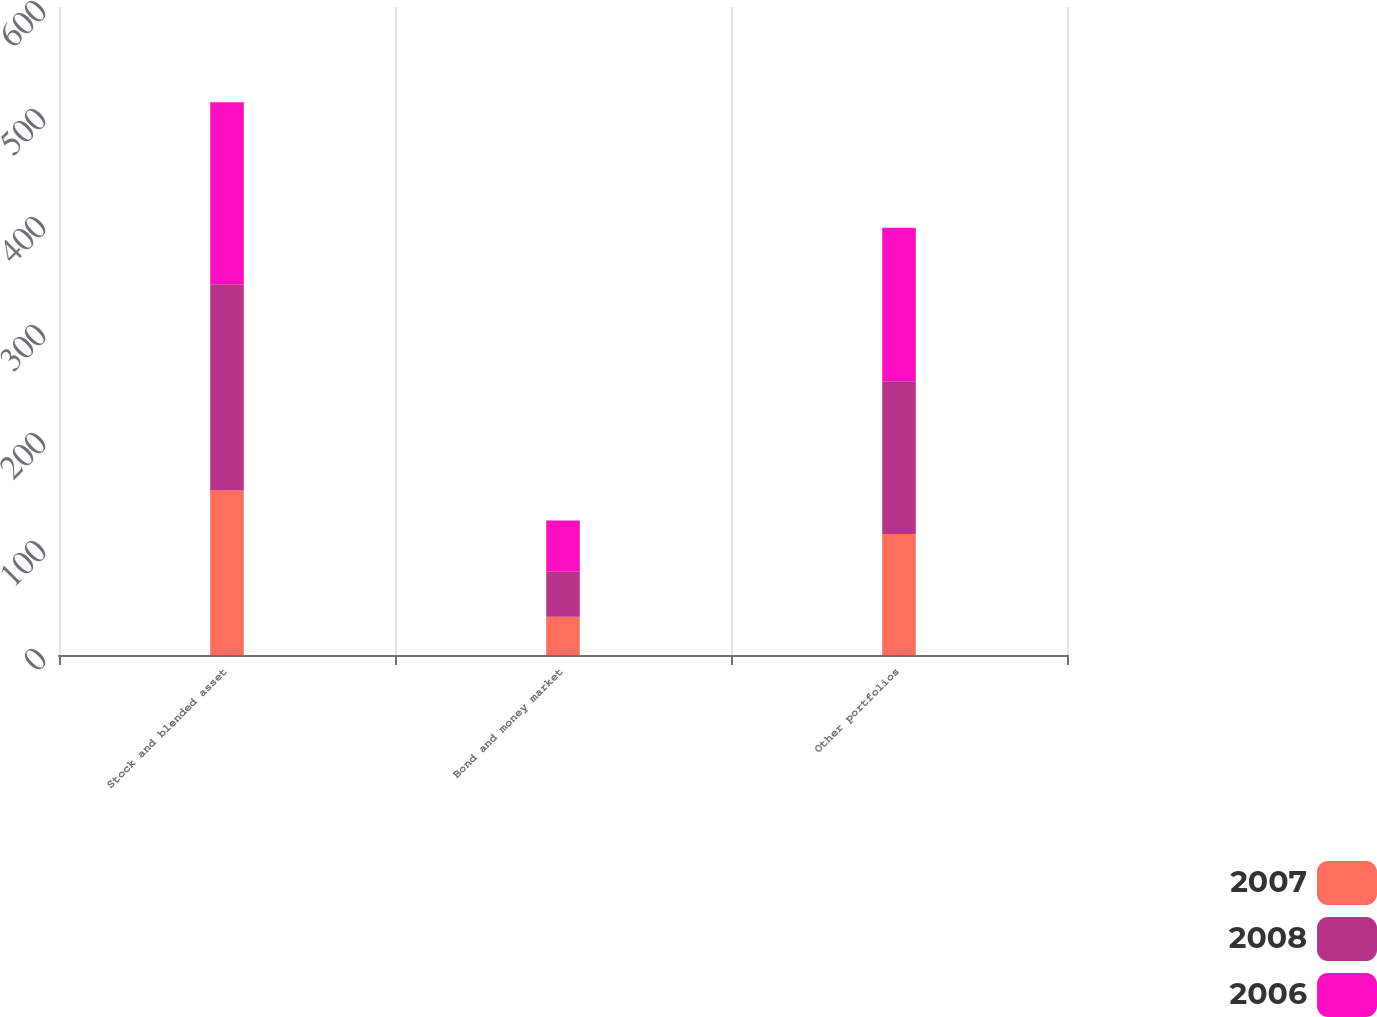<chart> <loc_0><loc_0><loc_500><loc_500><stacked_bar_chart><ecel><fcel>Stock and blended asset<fcel>Bond and money market<fcel>Other portfolios<nl><fcel>2007<fcel>152.2<fcel>35.4<fcel>112.1<nl><fcel>2008<fcel>191.1<fcel>41.7<fcel>141.4<nl><fcel>2006<fcel>168.6<fcel>47.5<fcel>142.1<nl></chart> 